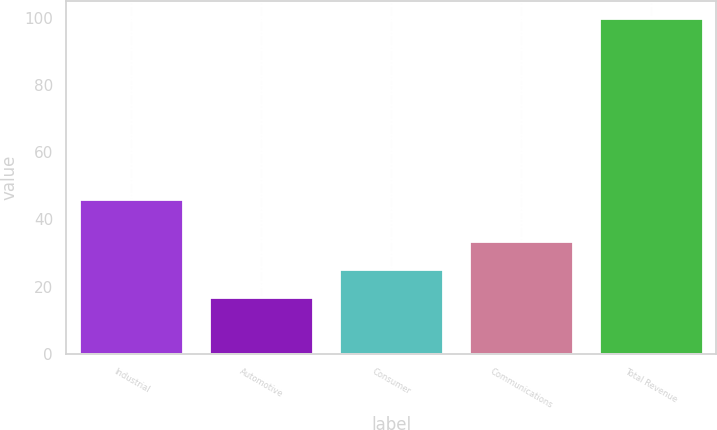Convert chart. <chart><loc_0><loc_0><loc_500><loc_500><bar_chart><fcel>Industrial<fcel>Automotive<fcel>Consumer<fcel>Communications<fcel>Total Revenue<nl><fcel>46<fcel>17<fcel>25.3<fcel>33.6<fcel>100<nl></chart> 